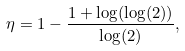<formula> <loc_0><loc_0><loc_500><loc_500>\eta = 1 - \frac { 1 + \log ( \log ( 2 ) ) } { \log ( 2 ) } ,</formula> 